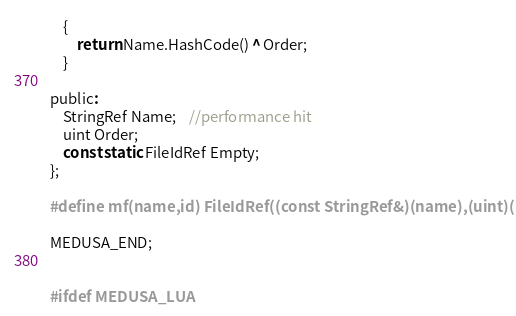<code> <loc_0><loc_0><loc_500><loc_500><_C_>	{
		return Name.HashCode() ^ Order;
	}

public:
	StringRef Name;	//performance hit
	uint Order;
	const static FileIdRef Empty;
};

#define mf(name,id) FileIdRef((const StringRef&)(name),(uint)(id))

MEDUSA_END;


#ifdef MEDUSA_LUA</code> 